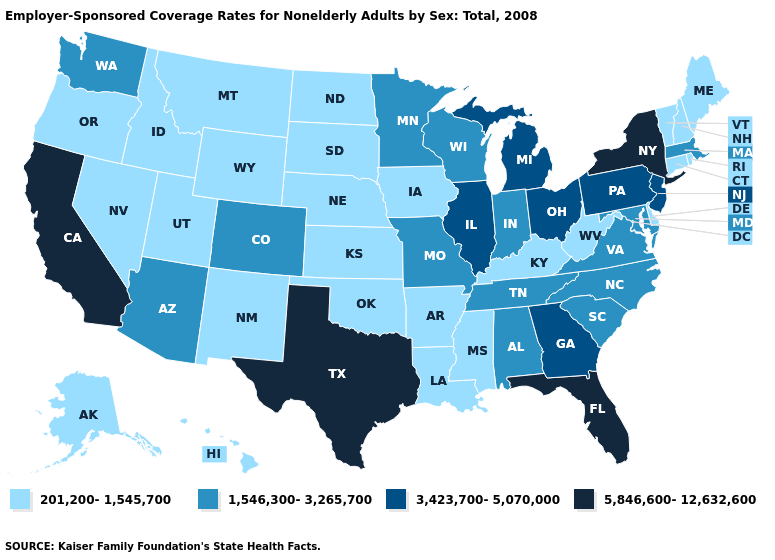Among the states that border New Mexico , which have the highest value?
Quick response, please. Texas. What is the highest value in the USA?
Keep it brief. 5,846,600-12,632,600. Name the states that have a value in the range 201,200-1,545,700?
Write a very short answer. Alaska, Arkansas, Connecticut, Delaware, Hawaii, Idaho, Iowa, Kansas, Kentucky, Louisiana, Maine, Mississippi, Montana, Nebraska, Nevada, New Hampshire, New Mexico, North Dakota, Oklahoma, Oregon, Rhode Island, South Dakota, Utah, Vermont, West Virginia, Wyoming. What is the value of New Hampshire?
Give a very brief answer. 201,200-1,545,700. What is the highest value in the MidWest ?
Be succinct. 3,423,700-5,070,000. Which states have the lowest value in the USA?
Write a very short answer. Alaska, Arkansas, Connecticut, Delaware, Hawaii, Idaho, Iowa, Kansas, Kentucky, Louisiana, Maine, Mississippi, Montana, Nebraska, Nevada, New Hampshire, New Mexico, North Dakota, Oklahoma, Oregon, Rhode Island, South Dakota, Utah, Vermont, West Virginia, Wyoming. Among the states that border Indiana , does Illinois have the highest value?
Concise answer only. Yes. What is the lowest value in the USA?
Keep it brief. 201,200-1,545,700. Does Oregon have the lowest value in the West?
Concise answer only. Yes. Name the states that have a value in the range 1,546,300-3,265,700?
Concise answer only. Alabama, Arizona, Colorado, Indiana, Maryland, Massachusetts, Minnesota, Missouri, North Carolina, South Carolina, Tennessee, Virginia, Washington, Wisconsin. Which states have the lowest value in the USA?
Keep it brief. Alaska, Arkansas, Connecticut, Delaware, Hawaii, Idaho, Iowa, Kansas, Kentucky, Louisiana, Maine, Mississippi, Montana, Nebraska, Nevada, New Hampshire, New Mexico, North Dakota, Oklahoma, Oregon, Rhode Island, South Dakota, Utah, Vermont, West Virginia, Wyoming. Does the first symbol in the legend represent the smallest category?
Write a very short answer. Yes. What is the lowest value in the USA?
Answer briefly. 201,200-1,545,700. What is the lowest value in the South?
Give a very brief answer. 201,200-1,545,700. What is the lowest value in states that border Maine?
Give a very brief answer. 201,200-1,545,700. 